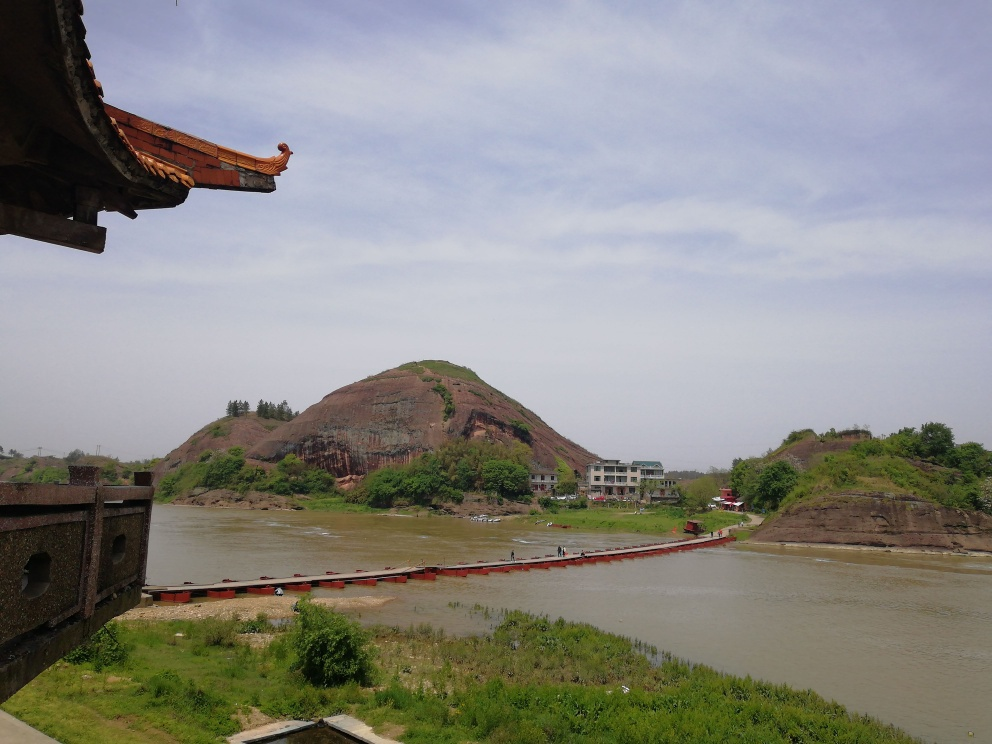What can you tell me about the architecture visible in the image? The architecture in the foreground, characterized by upturned eaves and ornamental ridge details, suggests East Asian influences, potentially Chinese. Such architectural elements are common in traditional Chinese buildings, typically found in temples, historical residences, or old palaces. 